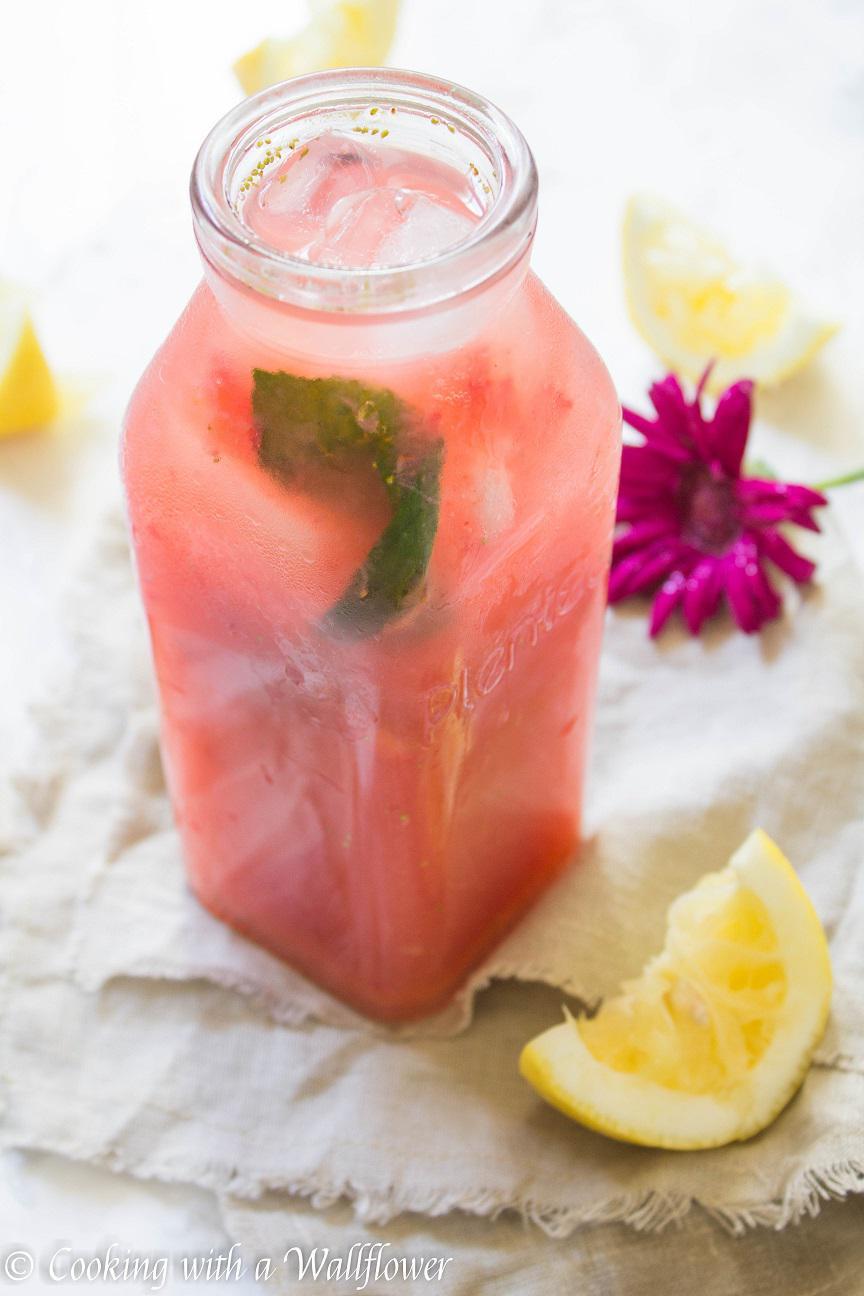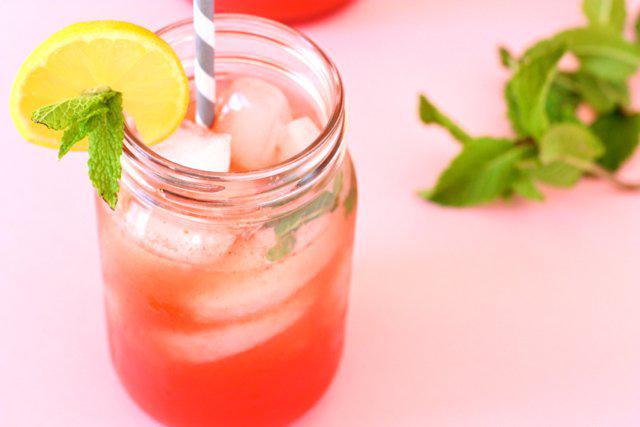The first image is the image on the left, the second image is the image on the right. For the images shown, is this caption "Exactly one prepared beverage glass is shown in each image." true? Answer yes or no. Yes. The first image is the image on the left, the second image is the image on the right. Considering the images on both sides, is "An image shows exactly one drink garnished with a yellow citrus slice and green leaves." valid? Answer yes or no. Yes. 